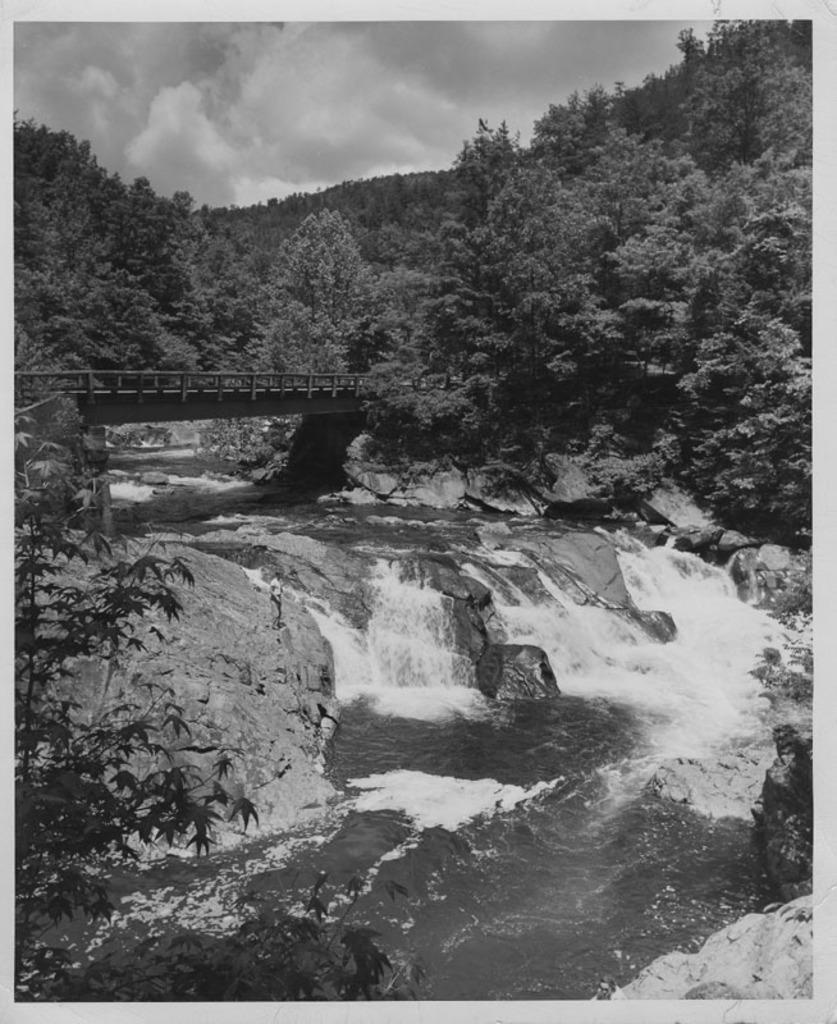What is present in the image that is related to water? There is water in the image. What type of vegetation can be seen in the image? There are trees in the image. What can be seen in the sky in the image? Clouds and the sky are visible in the image. What structure is present in the image that spans over the water? There is a bridge in the image. What is the color scheme of the image? The image is black and white in color. Where is the lift located in the image? There is no lift present in the image. What type of playground equipment can be seen in the image? There is no playground equipment, such as a swing, present in the image. 